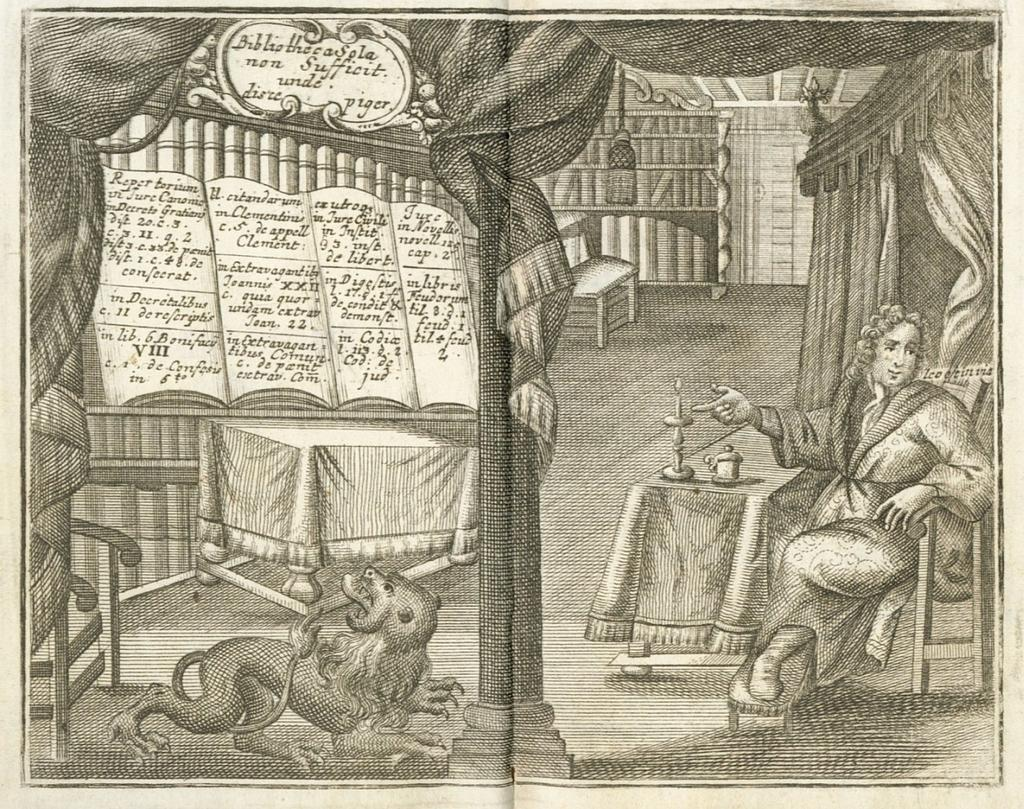What is featured on the poster in the image? The poster contains an image of a person and an image of an animal. What else can be seen in the image besides the poster? There are objects on a table in the image. What is the price of the basketball in the image? There is no basketball present in the image. What month is depicted in the image? The provided facts do not mention any specific month or time frame. 